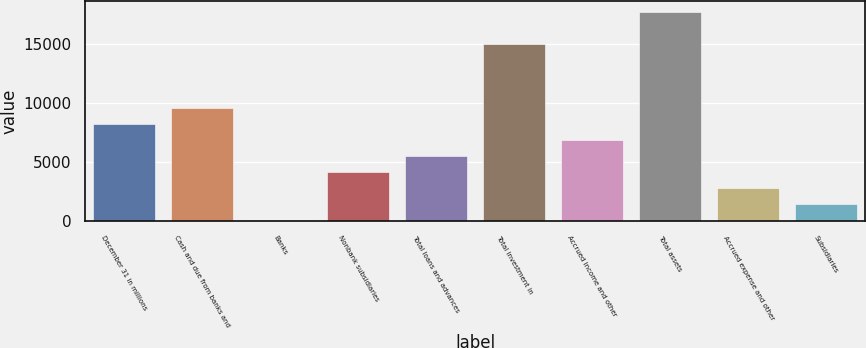Convert chart to OTSL. <chart><loc_0><loc_0><loc_500><loc_500><bar_chart><fcel>December 31 in millions<fcel>Cash and due from banks and<fcel>Banks<fcel>Nonbank subsidiaries<fcel>Total loans and advances<fcel>Total investment in<fcel>Accrued income and other<fcel>Total assets<fcel>Accrued expense and other<fcel>Subsidiaries<nl><fcel>8247<fcel>9606.5<fcel>90<fcel>4168.5<fcel>5528<fcel>15044.5<fcel>6887.5<fcel>17763.5<fcel>2809<fcel>1449.5<nl></chart> 